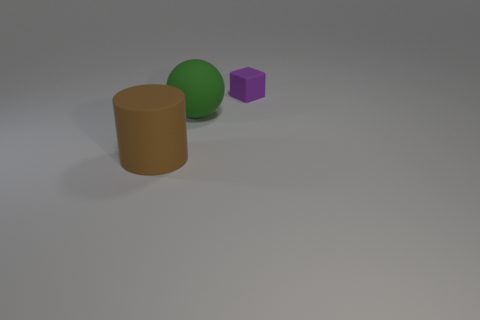Add 3 brown matte objects. How many objects exist? 6 Subtract all blocks. How many objects are left? 2 Subtract all cyan cylinders. Subtract all gray blocks. How many cylinders are left? 1 Subtract all tiny blue blocks. Subtract all big brown rubber cylinders. How many objects are left? 2 Add 2 big brown rubber cylinders. How many big brown rubber cylinders are left? 3 Add 1 tiny red metal cylinders. How many tiny red metal cylinders exist? 1 Subtract 1 purple blocks. How many objects are left? 2 